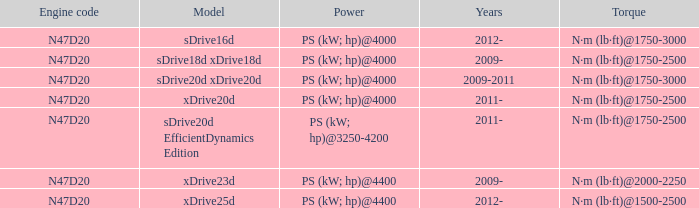What model is the n·m (lb·ft)@1500-2500 torque? Xdrive25d. 